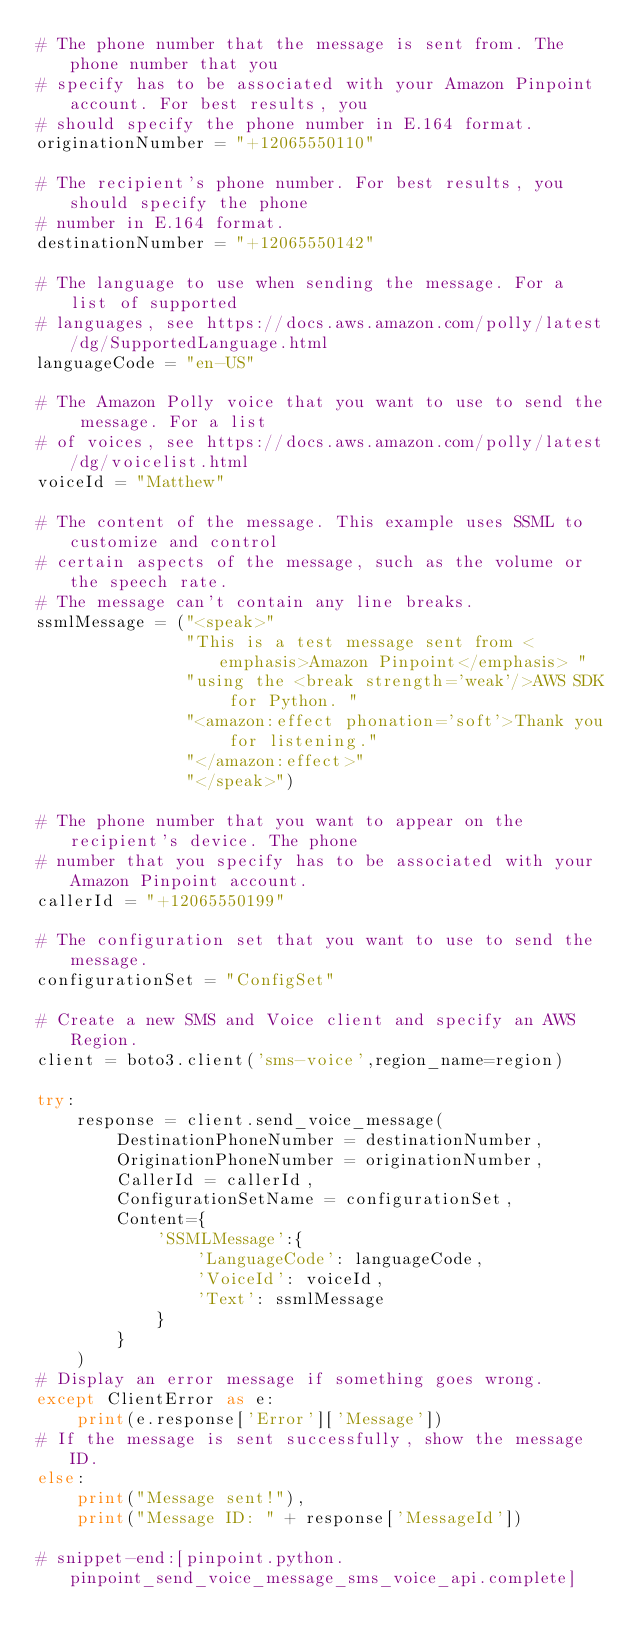Convert code to text. <code><loc_0><loc_0><loc_500><loc_500><_Python_># The phone number that the message is sent from. The phone number that you
# specify has to be associated with your Amazon Pinpoint account. For best results, you
# should specify the phone number in E.164 format.
originationNumber = "+12065550110"

# The recipient's phone number. For best results, you should specify the phone
# number in E.164 format.
destinationNumber = "+12065550142"

# The language to use when sending the message. For a list of supported
# languages, see https://docs.aws.amazon.com/polly/latest/dg/SupportedLanguage.html
languageCode = "en-US"

# The Amazon Polly voice that you want to use to send the message. For a list
# of voices, see https://docs.aws.amazon.com/polly/latest/dg/voicelist.html
voiceId = "Matthew"

# The content of the message. This example uses SSML to customize and control
# certain aspects of the message, such as the volume or the speech rate.
# The message can't contain any line breaks.
ssmlMessage = ("<speak>"
               "This is a test message sent from <emphasis>Amazon Pinpoint</emphasis> "
               "using the <break strength='weak'/>AWS SDK for Python. "
               "<amazon:effect phonation='soft'>Thank you for listening."
               "</amazon:effect>"
               "</speak>")

# The phone number that you want to appear on the recipient's device. The phone
# number that you specify has to be associated with your Amazon Pinpoint account.
callerId = "+12065550199"

# The configuration set that you want to use to send the message.
configurationSet = "ConfigSet"

# Create a new SMS and Voice client and specify an AWS Region.
client = boto3.client('sms-voice',region_name=region)

try:
    response = client.send_voice_message(
        DestinationPhoneNumber = destinationNumber,
        OriginationPhoneNumber = originationNumber,
        CallerId = callerId,
        ConfigurationSetName = configurationSet,
        Content={
            'SSMLMessage':{
                'LanguageCode': languageCode,
                'VoiceId': voiceId,
                'Text': ssmlMessage
            }
        }
    )
# Display an error message if something goes wrong.
except ClientError as e:
    print(e.response['Error']['Message'])
# If the message is sent successfully, show the message ID.
else:
    print("Message sent!"),
    print("Message ID: " + response['MessageId'])

# snippet-end:[pinpoint.python.pinpoint_send_voice_message_sms_voice_api.complete]
</code> 